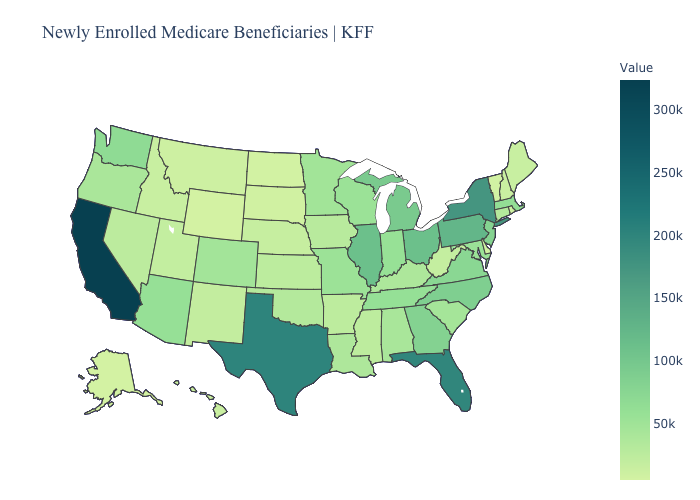Among the states that border California , does Nevada have the lowest value?
Answer briefly. Yes. Is the legend a continuous bar?
Be succinct. Yes. Among the states that border Texas , does Oklahoma have the lowest value?
Concise answer only. No. Does Wyoming have the lowest value in the West?
Answer briefly. Yes. Is the legend a continuous bar?
Short answer required. Yes. Among the states that border Wyoming , does Colorado have the highest value?
Be succinct. Yes. Does Wyoming have the lowest value in the USA?
Answer briefly. Yes. 